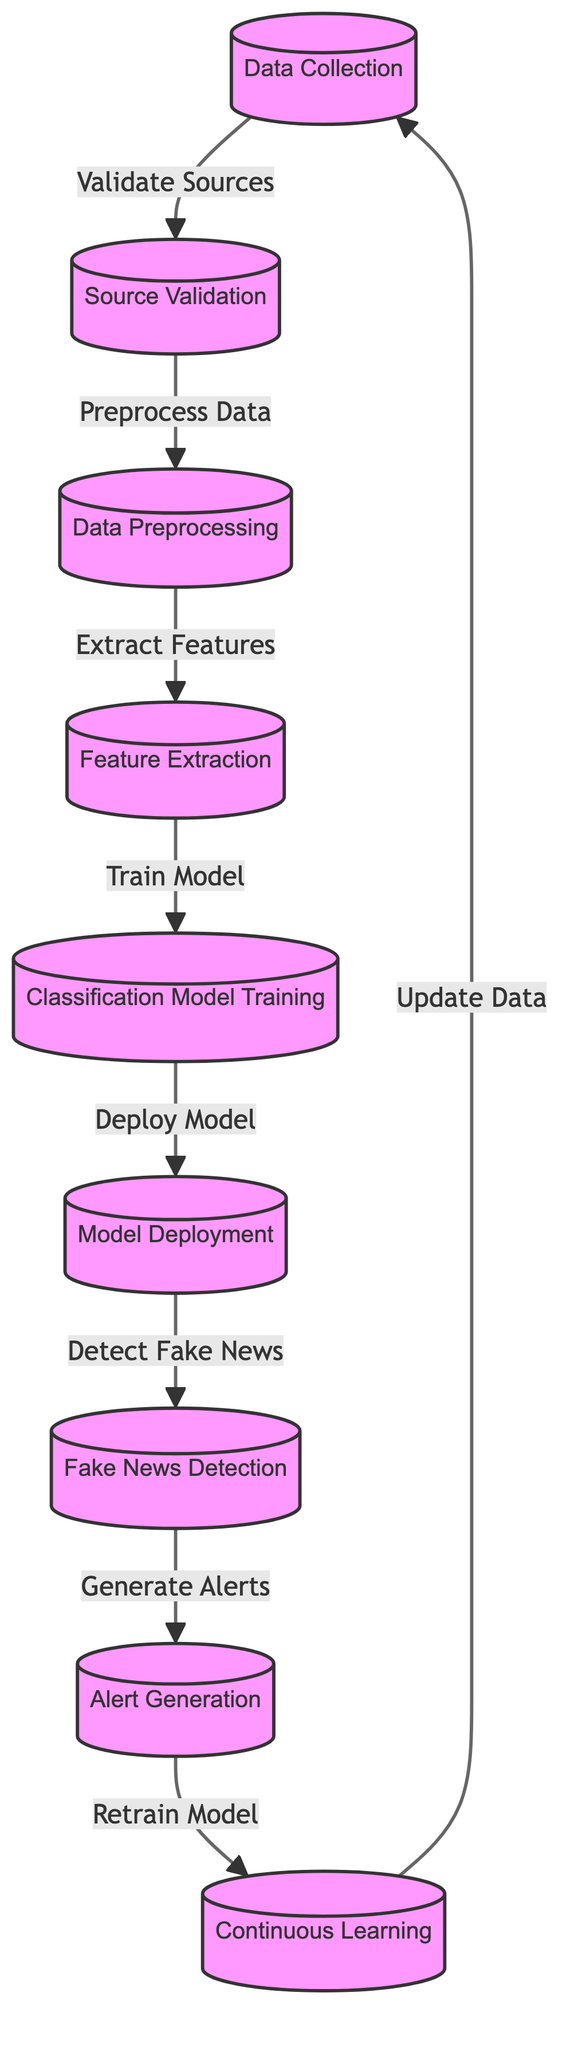What is the first step in the pipeline? The first step, as indicated in the diagram, is "Data Collection." This node starts the workflow for disinformation detection.
Answer: Data Collection How many nodes are present in the diagram? By counting each labeled process in the diagram, there are a total of nine nodes that represent different stages in the disinformation detection workflow.
Answer: Nine What does the "Source Validation" step lead to? The "Source Validation" node directly leads to the "Data Preprocessing" step, indicating that validated sources of information must be processed next.
Answer: Data Preprocessing What is generated after detecting fake news? After the "Fake News Detection" node, the next step is "Alert Generation," where alerts are produced based on identified fake news.
Answer: Alert Generation How many steps are there before model deployment? To reach the "Model Deployment" node, there are four preceding steps: "Data Collection," "Source Validation," "Data Preprocessing," and "Feature Extraction."
Answer: Four Which node represents the final stage of continuous improvement? The final node in this workflow, which signifies ongoing enhancement of the system, is "Continuous Learning." This step ensures that the model adapts over time.
Answer: Continuous Learning What step follows model deployment? Immediately following the "Model Deployment" stage in the pipeline is the "Fake News Detection" stage, where the deployed model is utilized to identify disinformation.
Answer: Fake News Detection Which process involves updating the model? The "Retrain Model" process is where the model is updated based on new learnings, ensuring it remains effective against fake news.
Answer: Retrain Model What is the primary function of the "Feature Extraction" node? The "Feature Extraction" node is responsible for transforming raw data into a set of features that can be utilized in the classification model.
Answer: Extract Features 